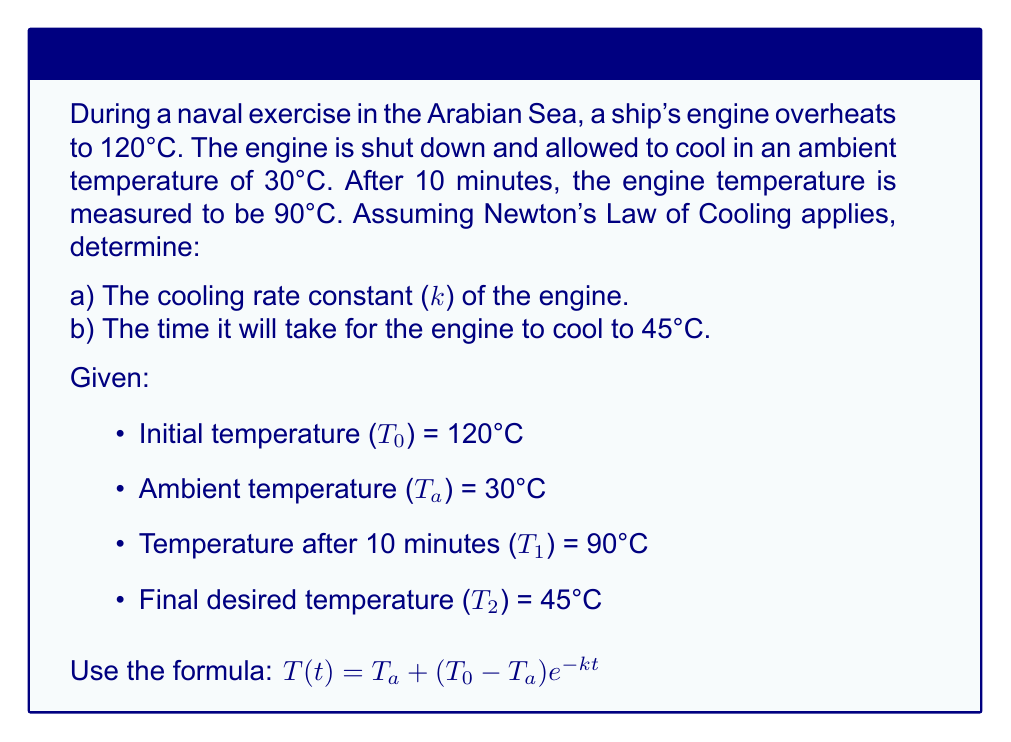Give your solution to this math problem. Let's solve this problem step by step:

1) First, we need to find the cooling rate constant (k).

   Using the formula $T(t) = T_a + (T_0 - T_a)e^{-kt}$, we can substitute the known values:

   $90 = 30 + (120 - 30)e^{-k(10)}$

2) Simplify:
   $60 = 90e^{-10k}$

3) Divide both sides by 90:
   $\frac{2}{3} = e^{-10k}$

4) Take natural log of both sides:
   $\ln(\frac{2}{3}) = -10k$

5) Solve for k:
   $k = -\frac{1}{10}\ln(\frac{2}{3}) \approx 0.0405$ min⁻¹

6) Now that we have k, we can find the time it takes to cool to 45°C.
   Use the same formula, but now solve for t:

   $45 = 30 + (120 - 30)e^{-0.0405t}$

7) Simplify:
   $15 = 90e^{-0.0405t}$

8) Divide both sides by 90:
   $\frac{1}{6} = e^{-0.0405t}$

9) Take natural log of both sides:
   $\ln(\frac{1}{6}) = -0.0405t$

10) Solve for t:
    $t = -\frac{1}{0.0405}\ln(\frac{1}{6}) \approx 44.7$ minutes
Answer: a) k ≈ 0.0405 min⁻¹
b) t ≈ 44.7 minutes 